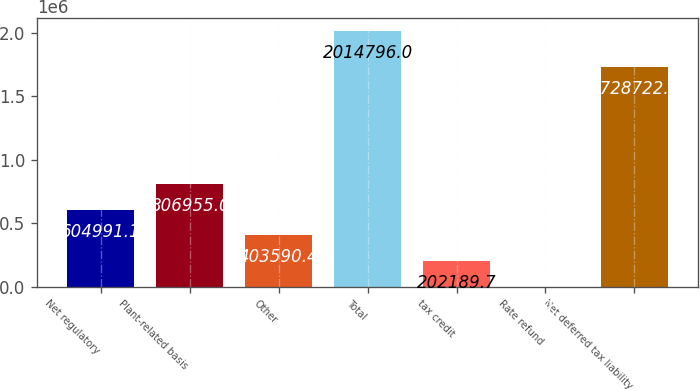Convert chart to OTSL. <chart><loc_0><loc_0><loc_500><loc_500><bar_chart><fcel>Net regulatory<fcel>Plant-related basis<fcel>Other<fcel>Total<fcel>tax credit<fcel>Rate refund<fcel>Net deferred tax liability<nl><fcel>604991<fcel>806955<fcel>403590<fcel>2.0148e+06<fcel>202190<fcel>789<fcel>1.72872e+06<nl></chart> 